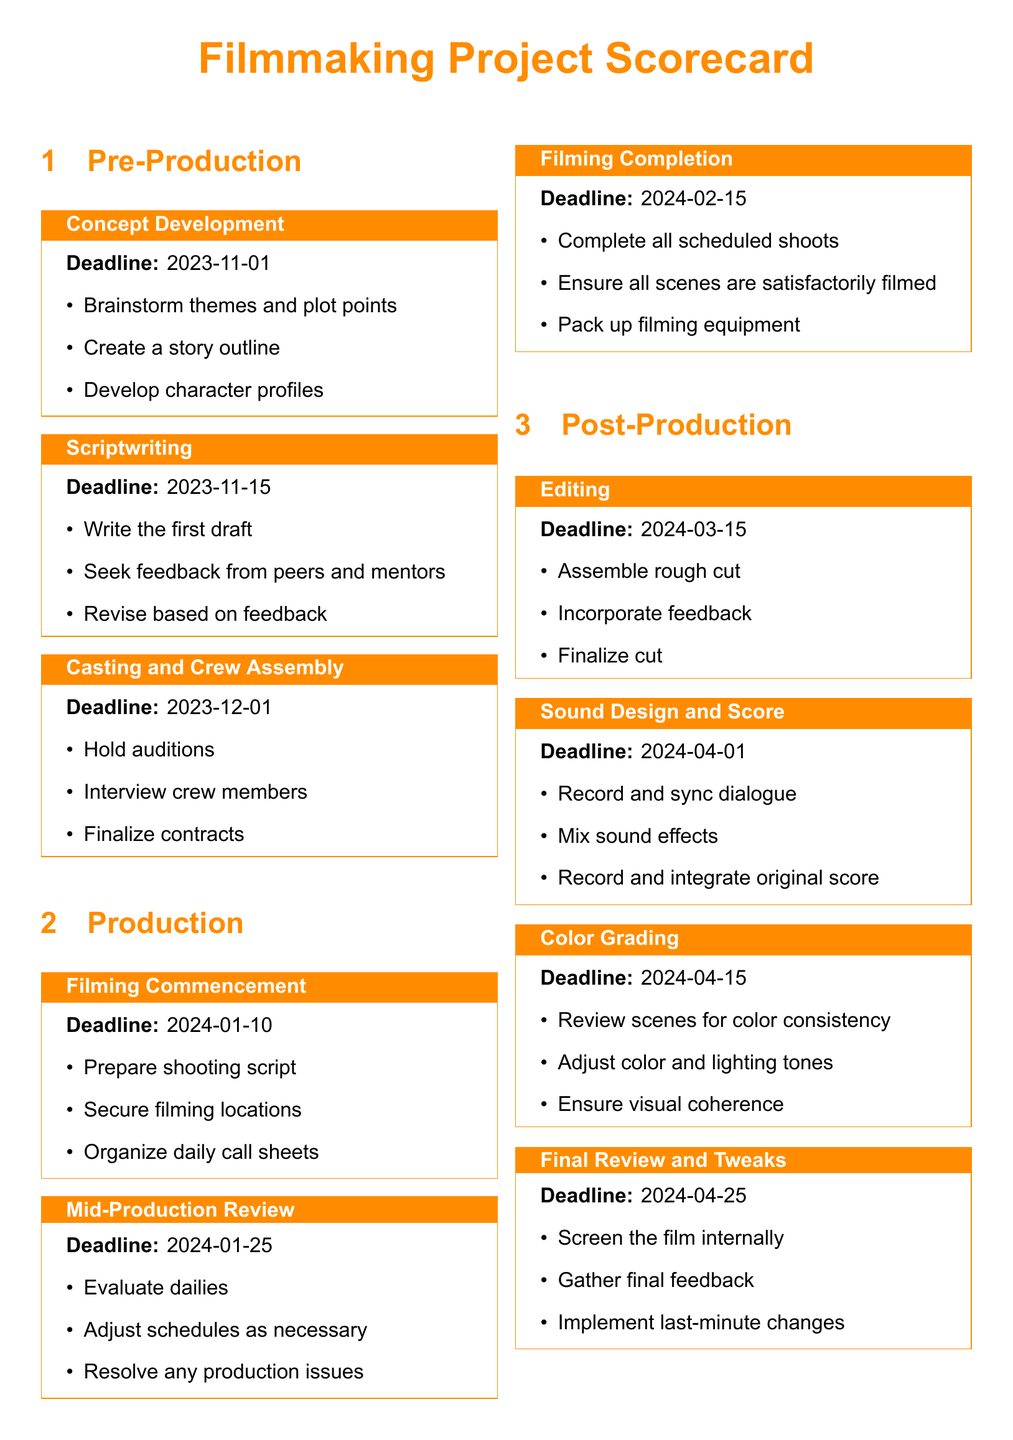What is the deadline for Concept Development? The deadline for Concept Development is specified in the document as 2023-11-01.
Answer: 2023-11-01 What is included in the Mid-Production Review milestones? The Mid-Production Review includes evaluating dailies, adjusting schedules, and resolving production issues.
Answer: Evaluate dailies, adjust schedules, resolve issues What is the deadline for the Film Premiere? The deadline for the Film Premiere is documented as 2024-05-15.
Answer: 2024-05-15 How many milestones are there in the Post-Production section? The Post-Production section contains four milestones according to the document structure.
Answer: Four What task is associated with the deadline of 2024-04-25? The task associated with the deadline of 2024-04-25 is the Final Review and Tweaks.
Answer: Final Review and Tweaks What specific task occurs during Casting and Crew Assembly? One specific task during Casting and Crew Assembly is to hold auditions.
Answer: Hold auditions Which milestone occurs immediately after Filming Completion? The milestone that occurs immediately after Filming Completion is Editing.
Answer: Editing What is the last milestone listed in the document? The last milestone listed in the document relates to the Theatrical Release.
Answer: Theatrical Release 